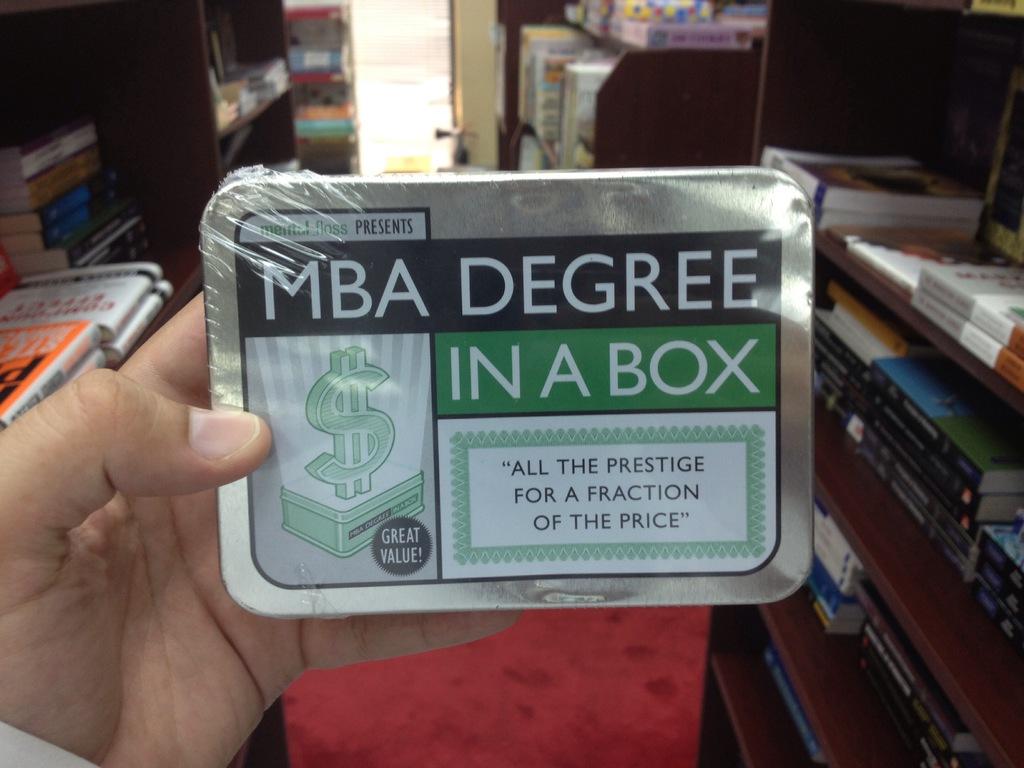What's in the box?
Your answer should be compact. Mba degree. What slogan is written on this box?
Give a very brief answer. All the prestige for a fraction of the price. 